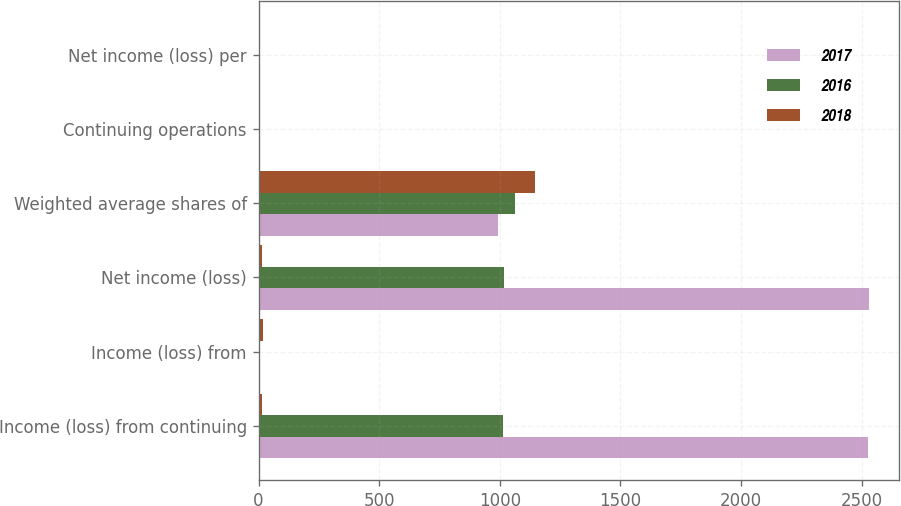Convert chart. <chart><loc_0><loc_0><loc_500><loc_500><stacked_bar_chart><ecel><fcel>Income (loss) from continuing<fcel>Income (loss) from<fcel>Net income (loss)<fcel>Weighted average shares of<fcel>Continuing operations<fcel>Net income (loss) per<nl><fcel>2017<fcel>2528<fcel>2<fcel>2530<fcel>991<fcel>2.58<fcel>2.55<nl><fcel>2016<fcel>1013<fcel>4<fcel>1017<fcel>1064<fcel>0.95<fcel>0.95<nl><fcel>2018<fcel>12.715<fcel>19<fcel>12.715<fcel>1144<fcel>6.43<fcel>6.35<nl></chart> 